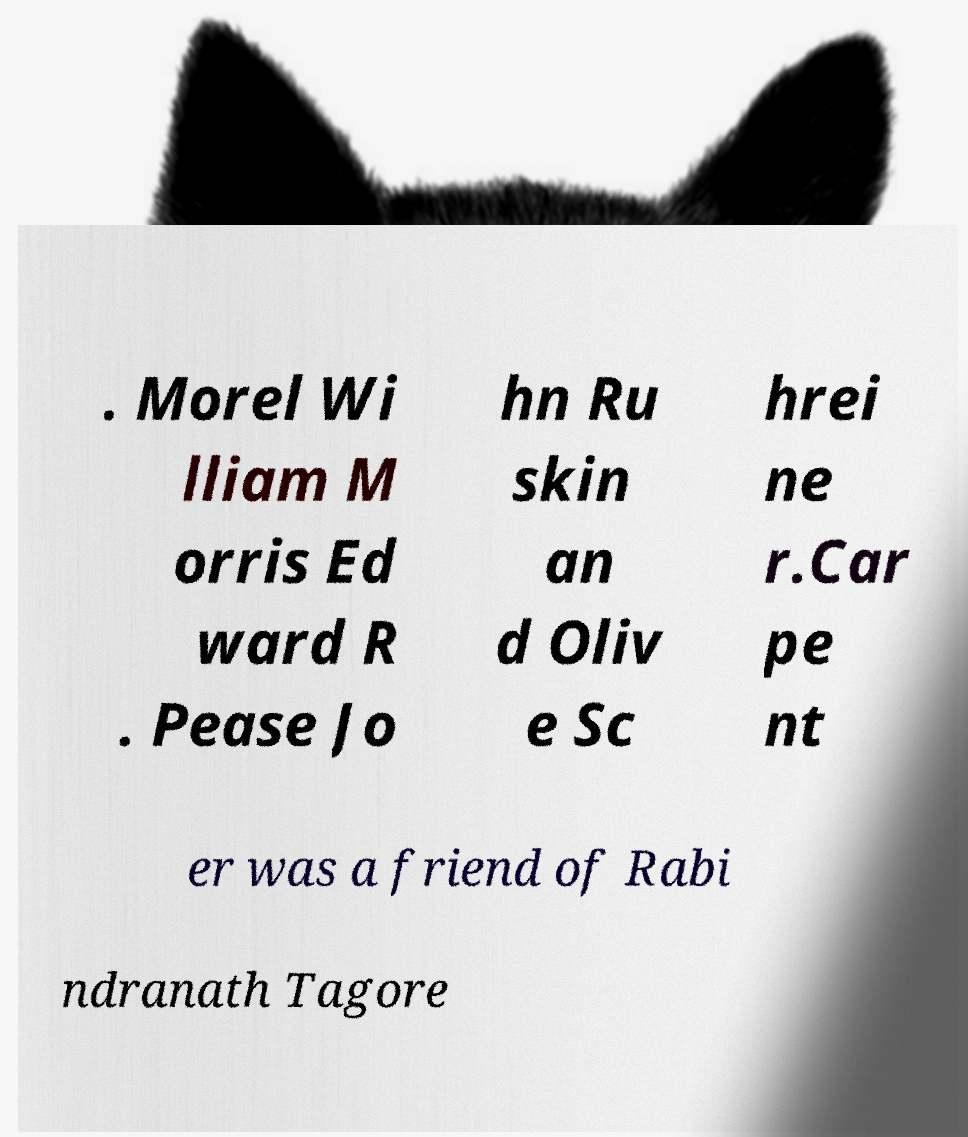Can you read and provide the text displayed in the image?This photo seems to have some interesting text. Can you extract and type it out for me? . Morel Wi lliam M orris Ed ward R . Pease Jo hn Ru skin an d Oliv e Sc hrei ne r.Car pe nt er was a friend of Rabi ndranath Tagore 